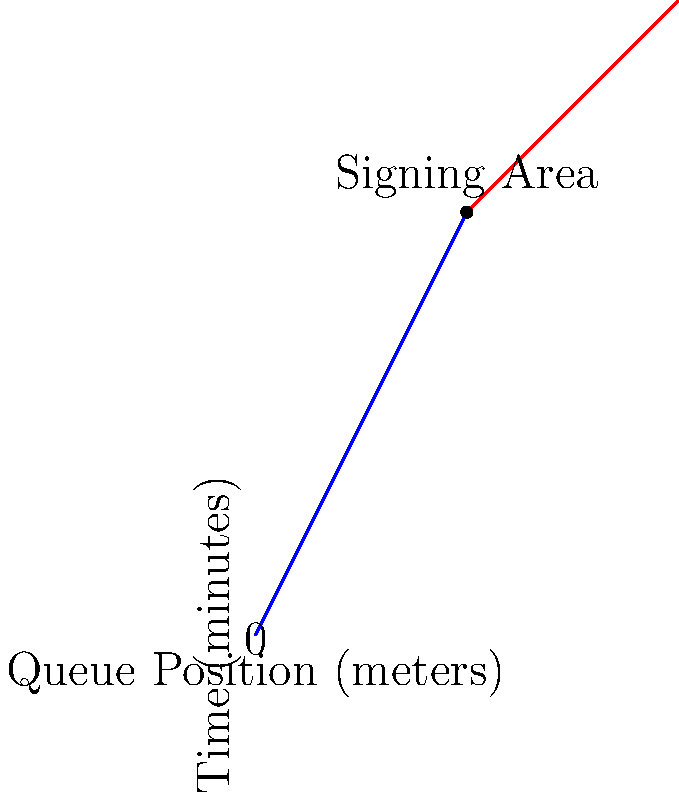At a book signing event, you've set up a linear queue system where the x-axis represents the queue position in meters, and the y-axis represents the waiting time in minutes. The blue line shows the initial queue progress, and the red line shows the progress after reaching the signing area. If an attendee joins the queue at position 30 meters, how long will they wait before reaching the author for their book signing? To solve this problem, we need to follow these steps:

1. Analyze the graph:
   - The blue line represents the initial queue progress (0 to 20 meters)
   - The red line represents the progress after the signing area (20 to 40 meters)
   - The queue moves at different rates before and after the signing area

2. Calculate the rate of progress for each segment:
   - Blue line: 40 minutes / 20 meters = 2 minutes/meter
   - Red line: 20 minutes / 20 meters = 1 minute/meter

3. Determine the attendee's position relative to the signing area:
   - Attendee joins at 30 meters
   - Signing area is at 20 meters
   - Distance to cover: 30 - 20 = 10 meters

4. Calculate the waiting time:
   - Time in red segment: 10 meters × 1 minute/meter = 10 minutes

5. Add the time spent in the signing area:
   - From the graph, we can see that the signing area is at the 40-minute mark
   - Total waiting time: 40 minutes + 10 minutes = 50 minutes

Therefore, an attendee joining the queue at 30 meters will wait 50 minutes before reaching the author for their book signing.
Answer: 50 minutes 